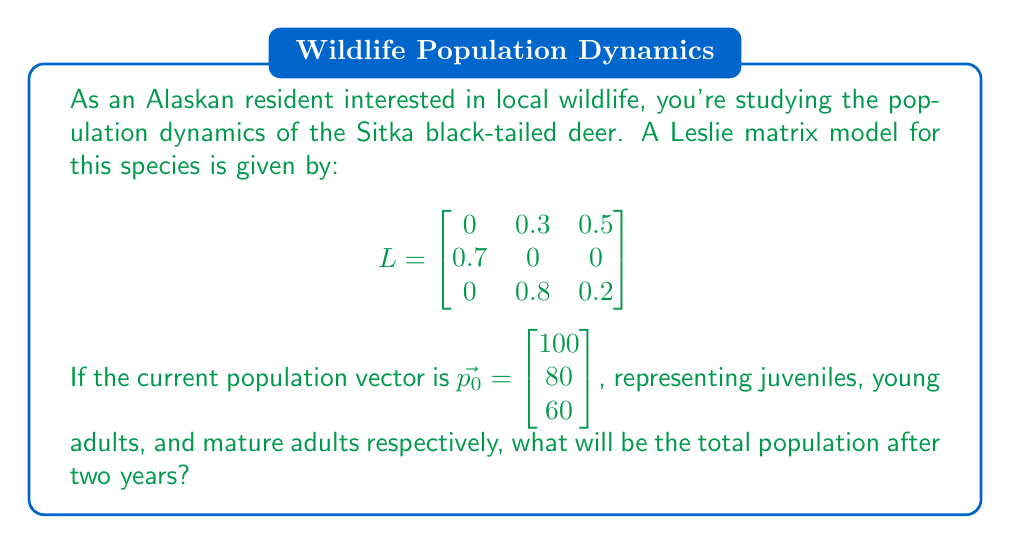Give your solution to this math problem. Let's approach this step-by-step:

1) The Leslie matrix $L$ represents the transition probabilities and fertility rates for the deer population. To find the population after two years, we need to multiply the matrix by the initial population vector twice.

2) First, let's calculate the population after one year:

   $\vec{p_1} = L \vec{p_0}$

   $$
   \begin{bmatrix}
   0 & 0.3 & 0.5 \\
   0.7 & 0 & 0 \\
   0 & 0.8 & 0.2
   \end{bmatrix}
   \begin{bmatrix}
   100 \\
   80 \\
   60
   \end{bmatrix}
   =
   \begin{bmatrix}
   (0 \times 100) + (0.3 \times 80) + (0.5 \times 60) \\
   (0.7 \times 100) + (0 \times 80) + (0 \times 60) \\
   (0 \times 100) + (0.8 \times 80) + (0.2 \times 60)
   \end{bmatrix}
   =
   \begin{bmatrix}
   54 \\
   70 \\
   76
   \end{bmatrix}
   $$

3) Now, let's calculate the population after two years:

   $\vec{p_2} = L \vec{p_1}$

   $$
   \begin{bmatrix}
   0 & 0.3 & 0.5 \\
   0.7 & 0 & 0 \\
   0 & 0.8 & 0.2
   \end{bmatrix}
   \begin{bmatrix}
   54 \\
   70 \\
   76
   \end{bmatrix}
   =
   \begin{bmatrix}
   (0 \times 54) + (0.3 \times 70) + (0.5 \times 76) \\
   (0.7 \times 54) + (0 \times 70) + (0 \times 76) \\
   (0 \times 54) + (0.8 \times 70) + (0.2 \times 76)
   \end{bmatrix}
   =
   \begin{bmatrix}
   59 \\
   37.8 \\
   71.2
   \end{bmatrix}
   $$

4) To find the total population, we sum the components of $\vec{p_2}$:

   Total population = 59 + 37.8 + 71.2 = 168

Therefore, the total population after two years will be 168 deer.
Answer: 168 